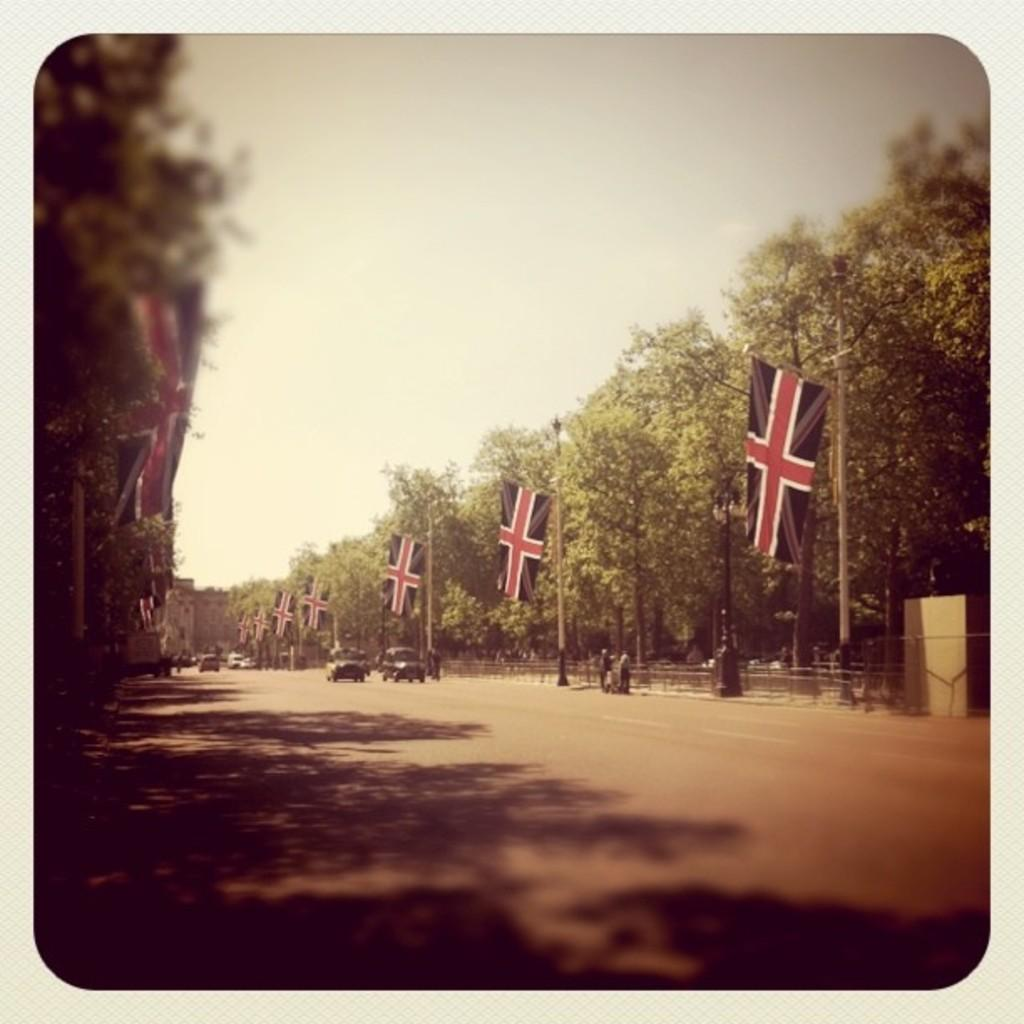What can be seen on the road in the image? There are vehicles on the road in the image. What else is present along the road in the image? There are flags on poles on the sides of the road. What type of natural elements can be seen in the image? There are trees in the image. What is visible in the background of the image? The sky is visible in the background of the image. What type of ink can be seen dripping from the trees in the image? There is no ink dripping from the trees in the image; it features vehicles on the road, flags on poles, trees, and a visible sky. How many elbows are visible on the vehicles in the image? There are no elbows visible on the vehicles in the image, as elbows are a part of the human body and not a feature of vehicles. 